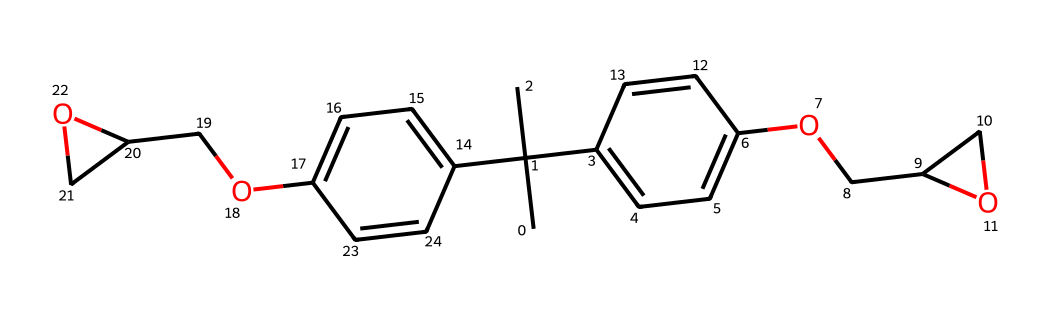What is the total number of carbon atoms in SU-8? By examining the SMILES representation, each 'C' indicates a carbon atom, and counting all occurrences gives a total of 18 carbon atoms.
Answer: 18 How many ether linkages are present in the structure? The ether linkages are typically indicated by the 'O' connecting two carbon chains. In the given SMILES, there are two such ether linkages present, identified by 'OCC'.
Answer: 2 What type of polymer is SU-8 classified as? SU-8 is an epoxy-based negative photoresist, meaning it undergoes polymerization in the presence of UV light. This classification is based on its functional groups and structure.
Answer: epoxy-based negative photoresist What functional group is indicated by the 'O' in the SMILES? The 'O' in the structure represents ether linkages that connect different carbon groups, contributing to the polymer's properties.
Answer: ether How many aromatic rings are present in the SU-8 structure? By analyzing the structure, we find two aromatic rings each represented by the 'c' in the SMILES notation, indicating that they are part of a cyclic, stable structure.
Answer: 2 What role do the hydroxyl (-OH) groups play in SU-8’s properties? Hydroxyl groups in the structure contribute to the solubility in specific solvents and are crucial for the cross-linking process during exposure to UV light.
Answer: solubility and cross-linking What is the main reason for choosing SU-8 as a photoresist in microfabrication? SU-8's high contrast and resolution in negative-tone processes make it suitable for creating fine features in microfabrication. It polymerizes where exposed to UV light, forming a stable pattern.
Answer: high contrast and resolution 